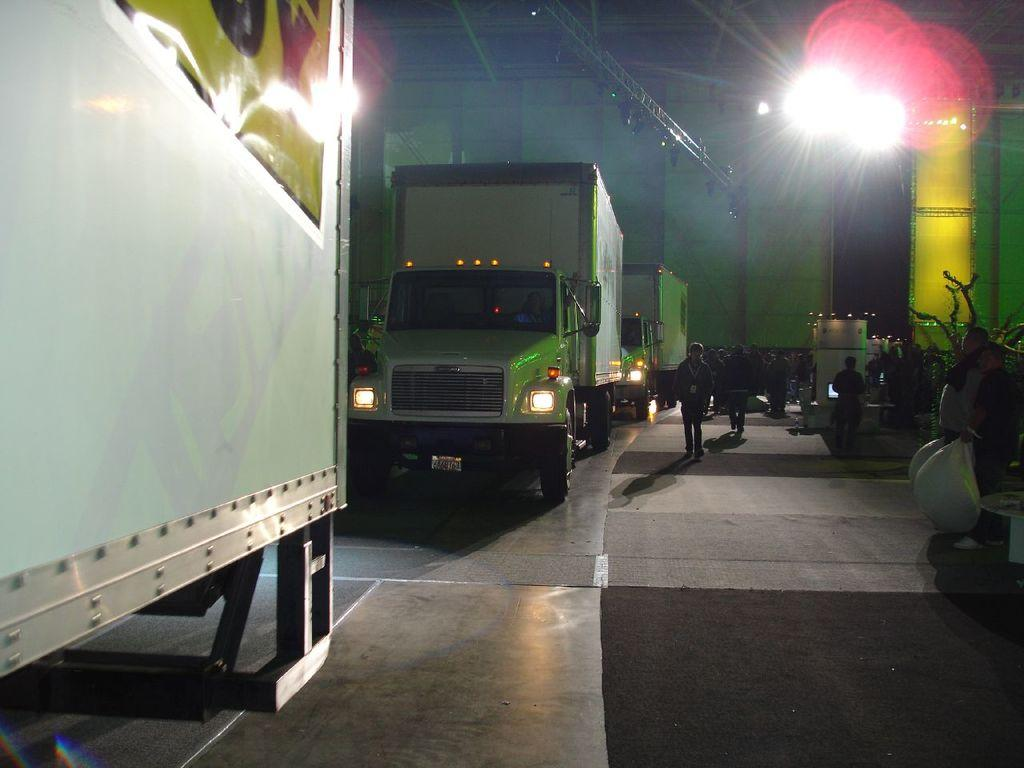What can be seen in the image related to transportation? There are vehicles in the image. Are there any people present in the image? Yes, there are people in the image. What is a person doing with their hands in the image? A person is holding some objects in the image. What can be seen in the image that provides illumination? There are lights in the image. What material is used to create a long, thin structure in the image? There is a metal rod in the image. What is visible on the floor in the image? There are other objects on the floor in the image. What type of bubble is floating above the vehicles in the image? There is no bubble present in the image. What religious symbols can be seen in the image? There is no mention of religious symbols in the image. 